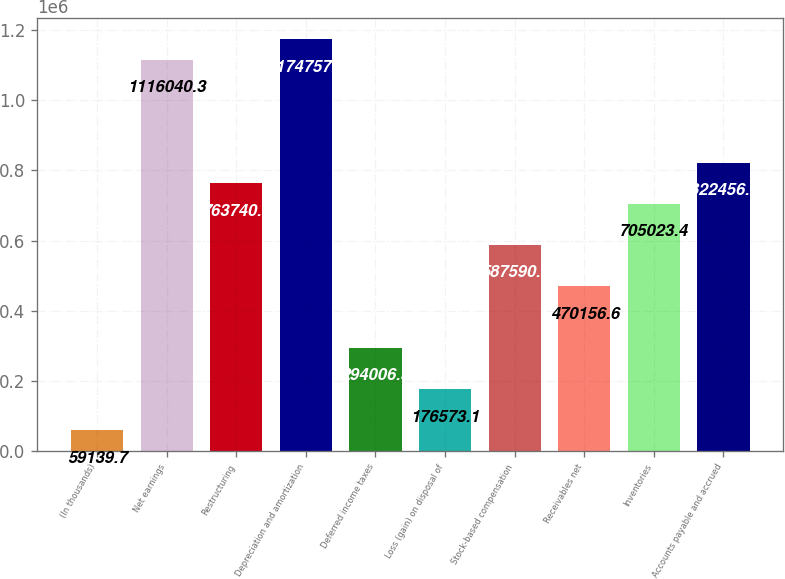Convert chart. <chart><loc_0><loc_0><loc_500><loc_500><bar_chart><fcel>(In thousands)<fcel>Net earnings<fcel>Restructuring<fcel>Depreciation and amortization<fcel>Deferred income taxes<fcel>Loss (gain) on disposal of<fcel>Stock-based compensation<fcel>Receivables net<fcel>Inventories<fcel>Accounts payable and accrued<nl><fcel>59139.7<fcel>1.11604e+06<fcel>763740<fcel>1.17476e+06<fcel>294006<fcel>176573<fcel>587590<fcel>470157<fcel>705023<fcel>822457<nl></chart> 